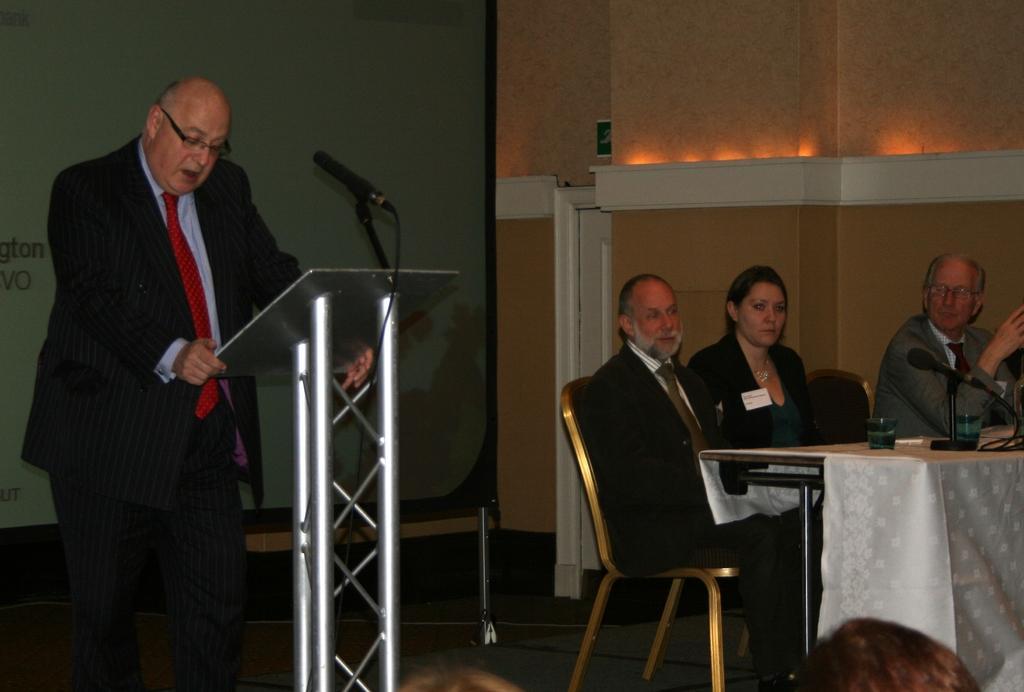How would you summarize this image in a sentence or two? This is a picture of a meeting. On the left there is a man standing in black suit and talking. In the center there is a stand and a microphone. On the right there is a table, on the table there are glasses. In front of the table there are chairs in the chairs there are three people seated wearing suits. In the background there is a wall. On the right there is a person. 